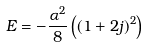<formula> <loc_0><loc_0><loc_500><loc_500>E = - \frac { \alpha ^ { 2 } } { 8 } \left ( ( 1 + 2 j ) ^ { 2 } \right )</formula> 